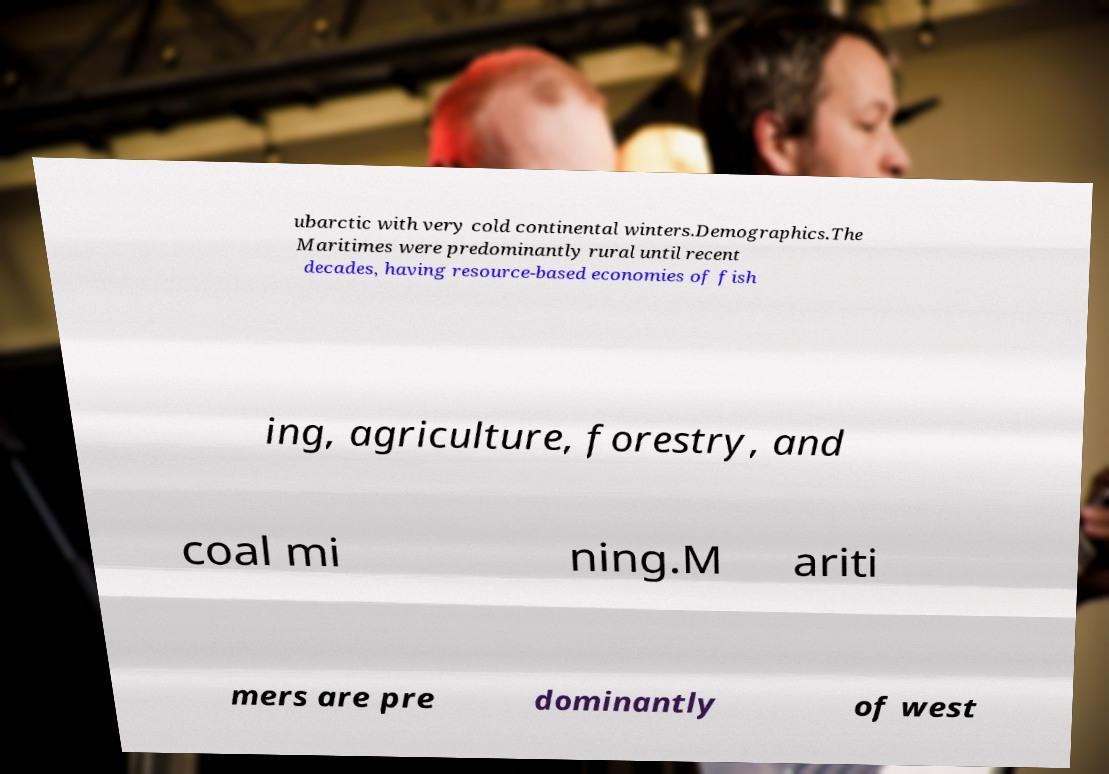I need the written content from this picture converted into text. Can you do that? ubarctic with very cold continental winters.Demographics.The Maritimes were predominantly rural until recent decades, having resource-based economies of fish ing, agriculture, forestry, and coal mi ning.M ariti mers are pre dominantly of west 